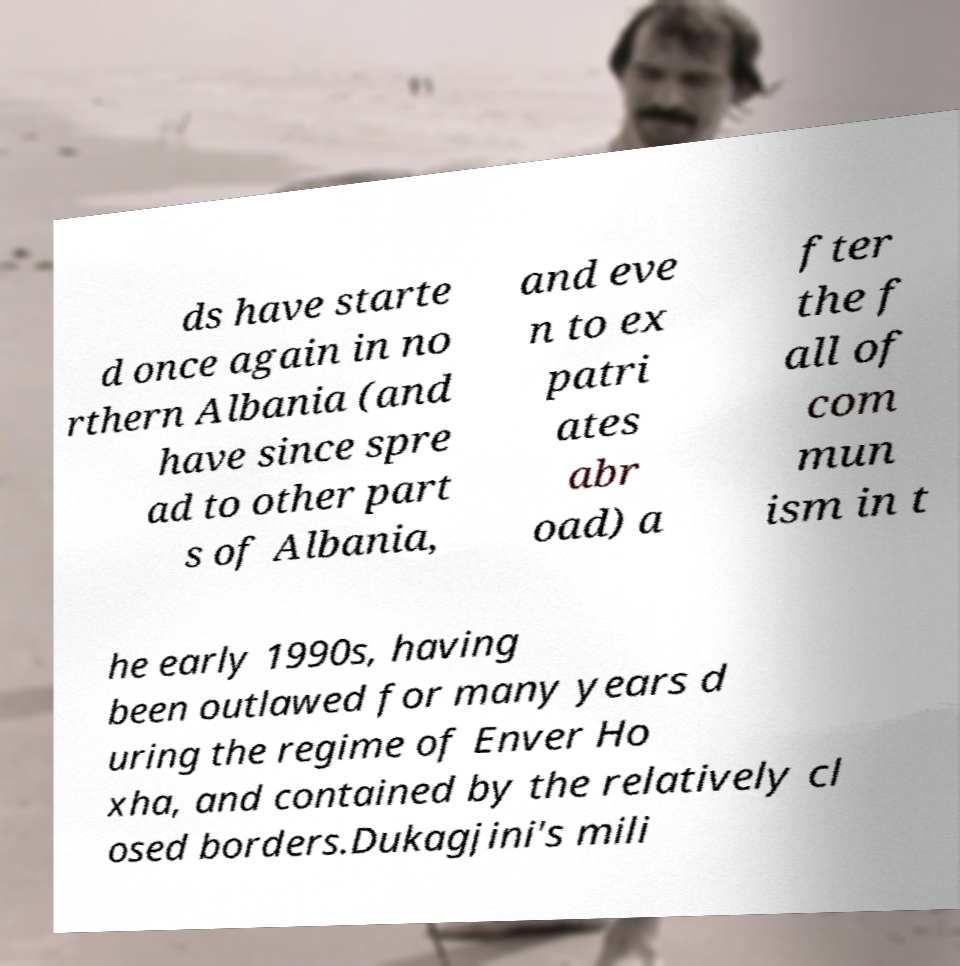Can you read and provide the text displayed in the image?This photo seems to have some interesting text. Can you extract and type it out for me? ds have starte d once again in no rthern Albania (and have since spre ad to other part s of Albania, and eve n to ex patri ates abr oad) a fter the f all of com mun ism in t he early 1990s, having been outlawed for many years d uring the regime of Enver Ho xha, and contained by the relatively cl osed borders.Dukagjini's mili 